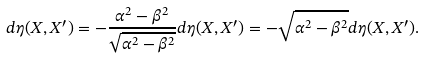<formula> <loc_0><loc_0><loc_500><loc_500>d \eta ( X , X ^ { \prime } ) = - \frac { \alpha ^ { 2 } - \beta ^ { 2 } } { \sqrt { \alpha ^ { 2 } - \beta ^ { 2 } } } d \eta ( X , X ^ { \prime } ) = - \sqrt { \alpha ^ { 2 } - \beta ^ { 2 } } d \eta ( X , X ^ { \prime } ) .</formula> 